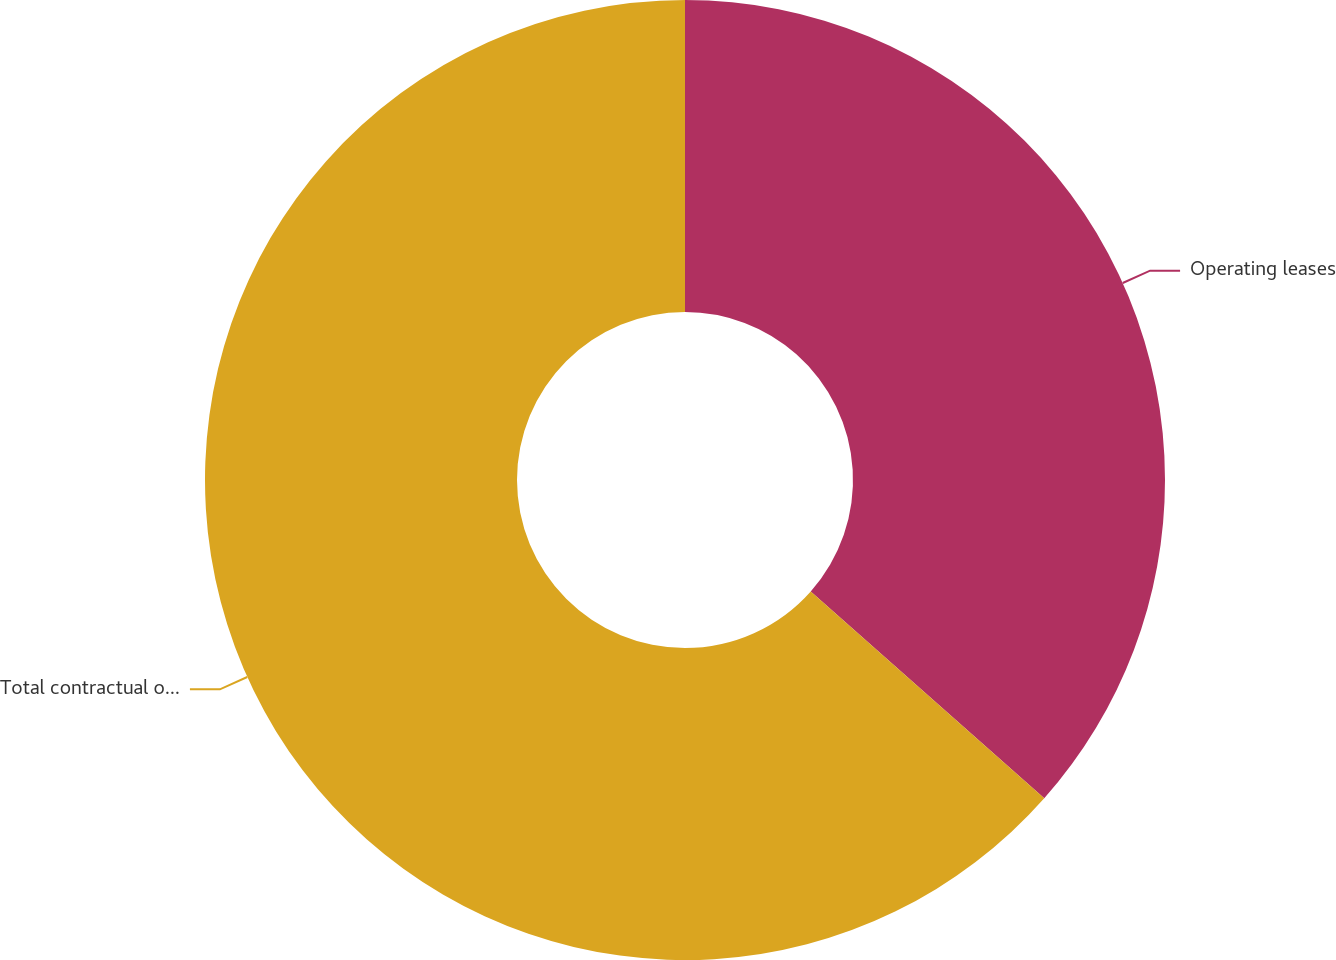Convert chart. <chart><loc_0><loc_0><loc_500><loc_500><pie_chart><fcel>Operating leases<fcel>Total contractual obligations<nl><fcel>36.54%<fcel>63.46%<nl></chart> 